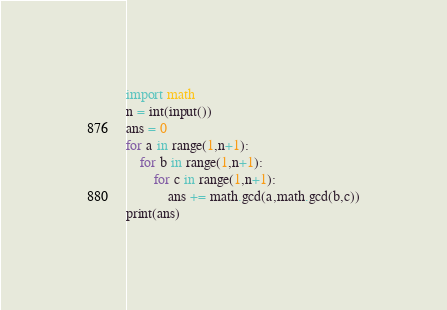<code> <loc_0><loc_0><loc_500><loc_500><_Python_>import math
n = int(input())
ans = 0
for a in range(1,n+1):
    for b in range(1,n+1):
        for c in range(1,n+1):
            ans += math.gcd(a,math.gcd(b,c))
print(ans)
</code> 